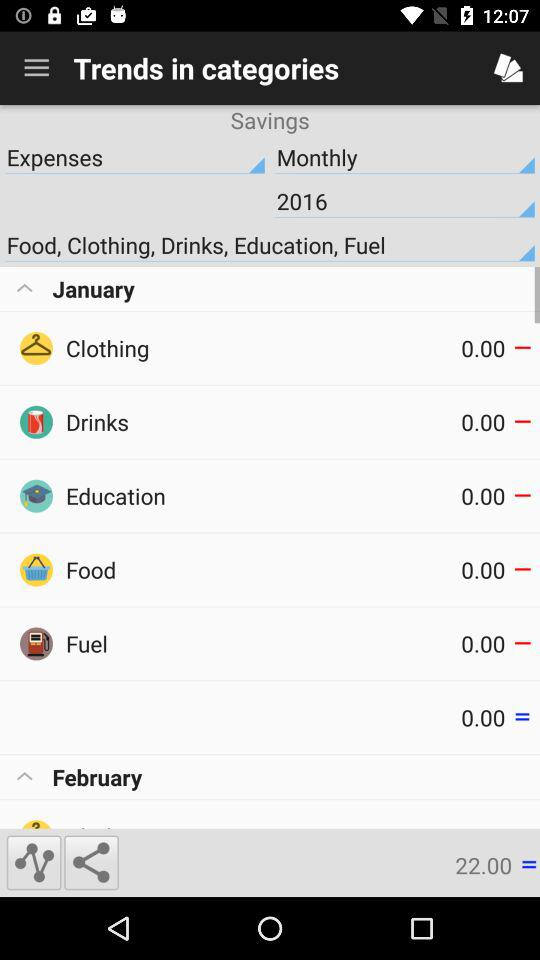How many months do I have data for?
Answer the question using a single word or phrase. 2 